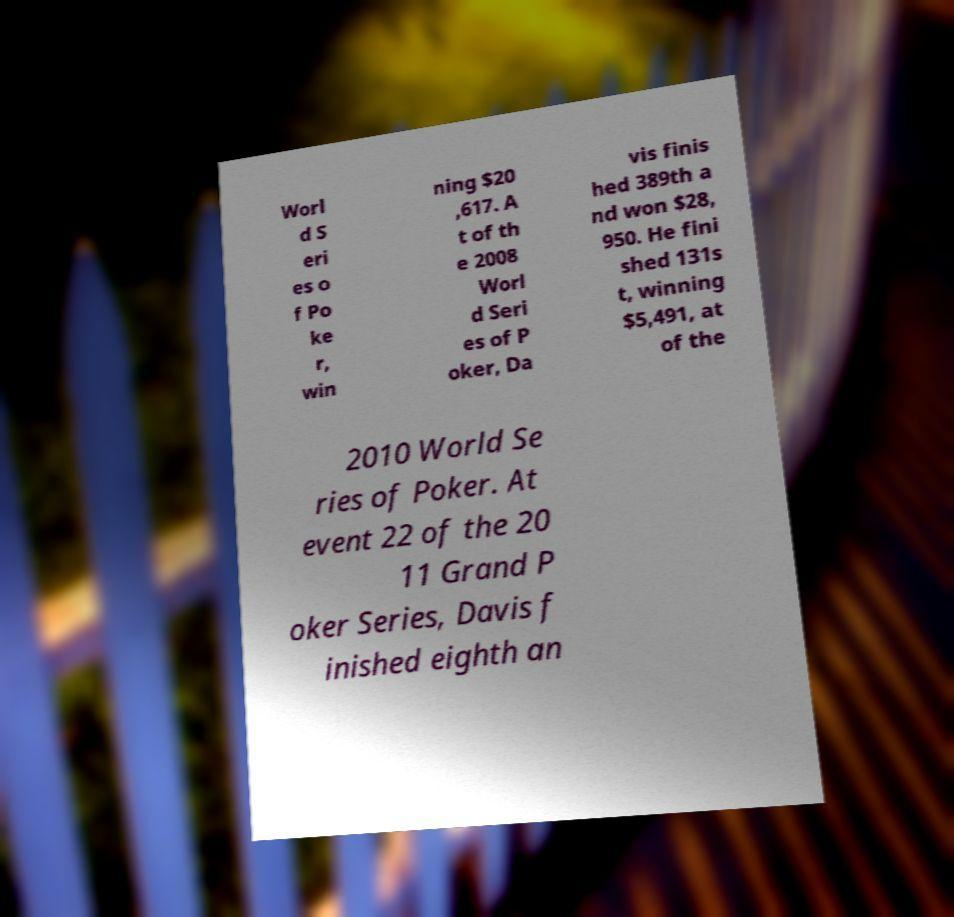Can you accurately transcribe the text from the provided image for me? Worl d S eri es o f Po ke r, win ning $20 ,617. A t of th e 2008 Worl d Seri es of P oker, Da vis finis hed 389th a nd won $28, 950. He fini shed 131s t, winning $5,491, at of the 2010 World Se ries of Poker. At event 22 of the 20 11 Grand P oker Series, Davis f inished eighth an 